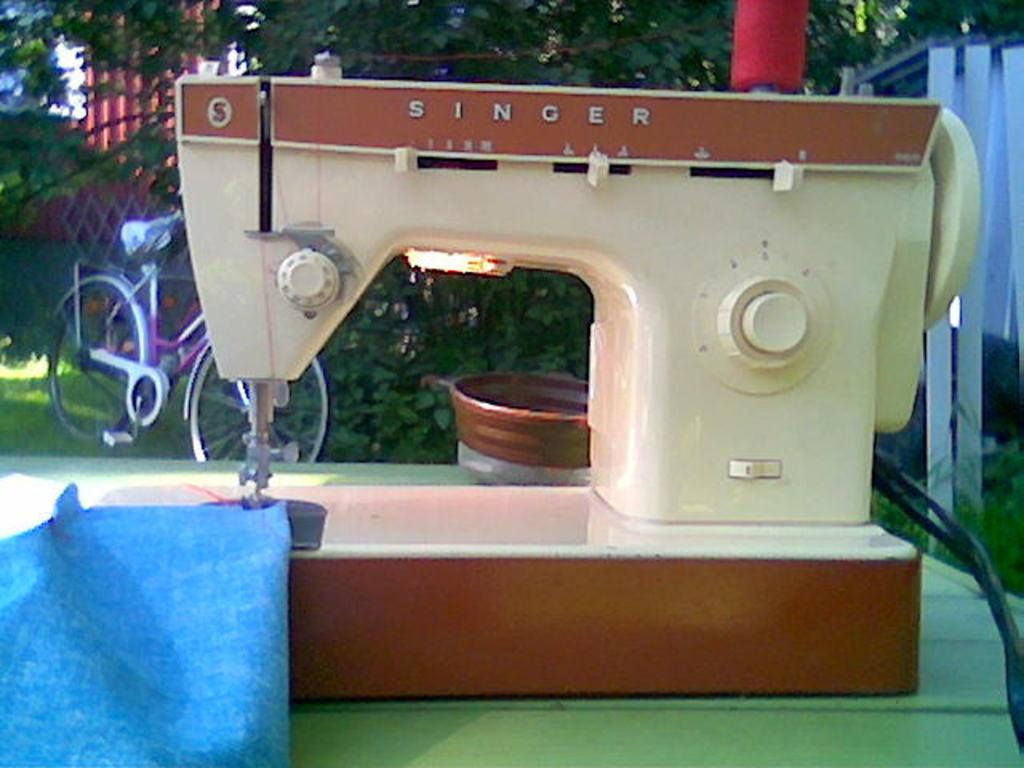What is the main object on the table in the image? There is a sewing machine on a table in the image. What can be seen in the background of the image? There is a cycle and trees in the background of the image. Are there any other objects visible in the background? Yes, there are some objects in the background of the image. How many mines are visible in the image? There are no mines present in the image. What type of planes can be seen flying in the background of the image? There are no planes visible in the image. 